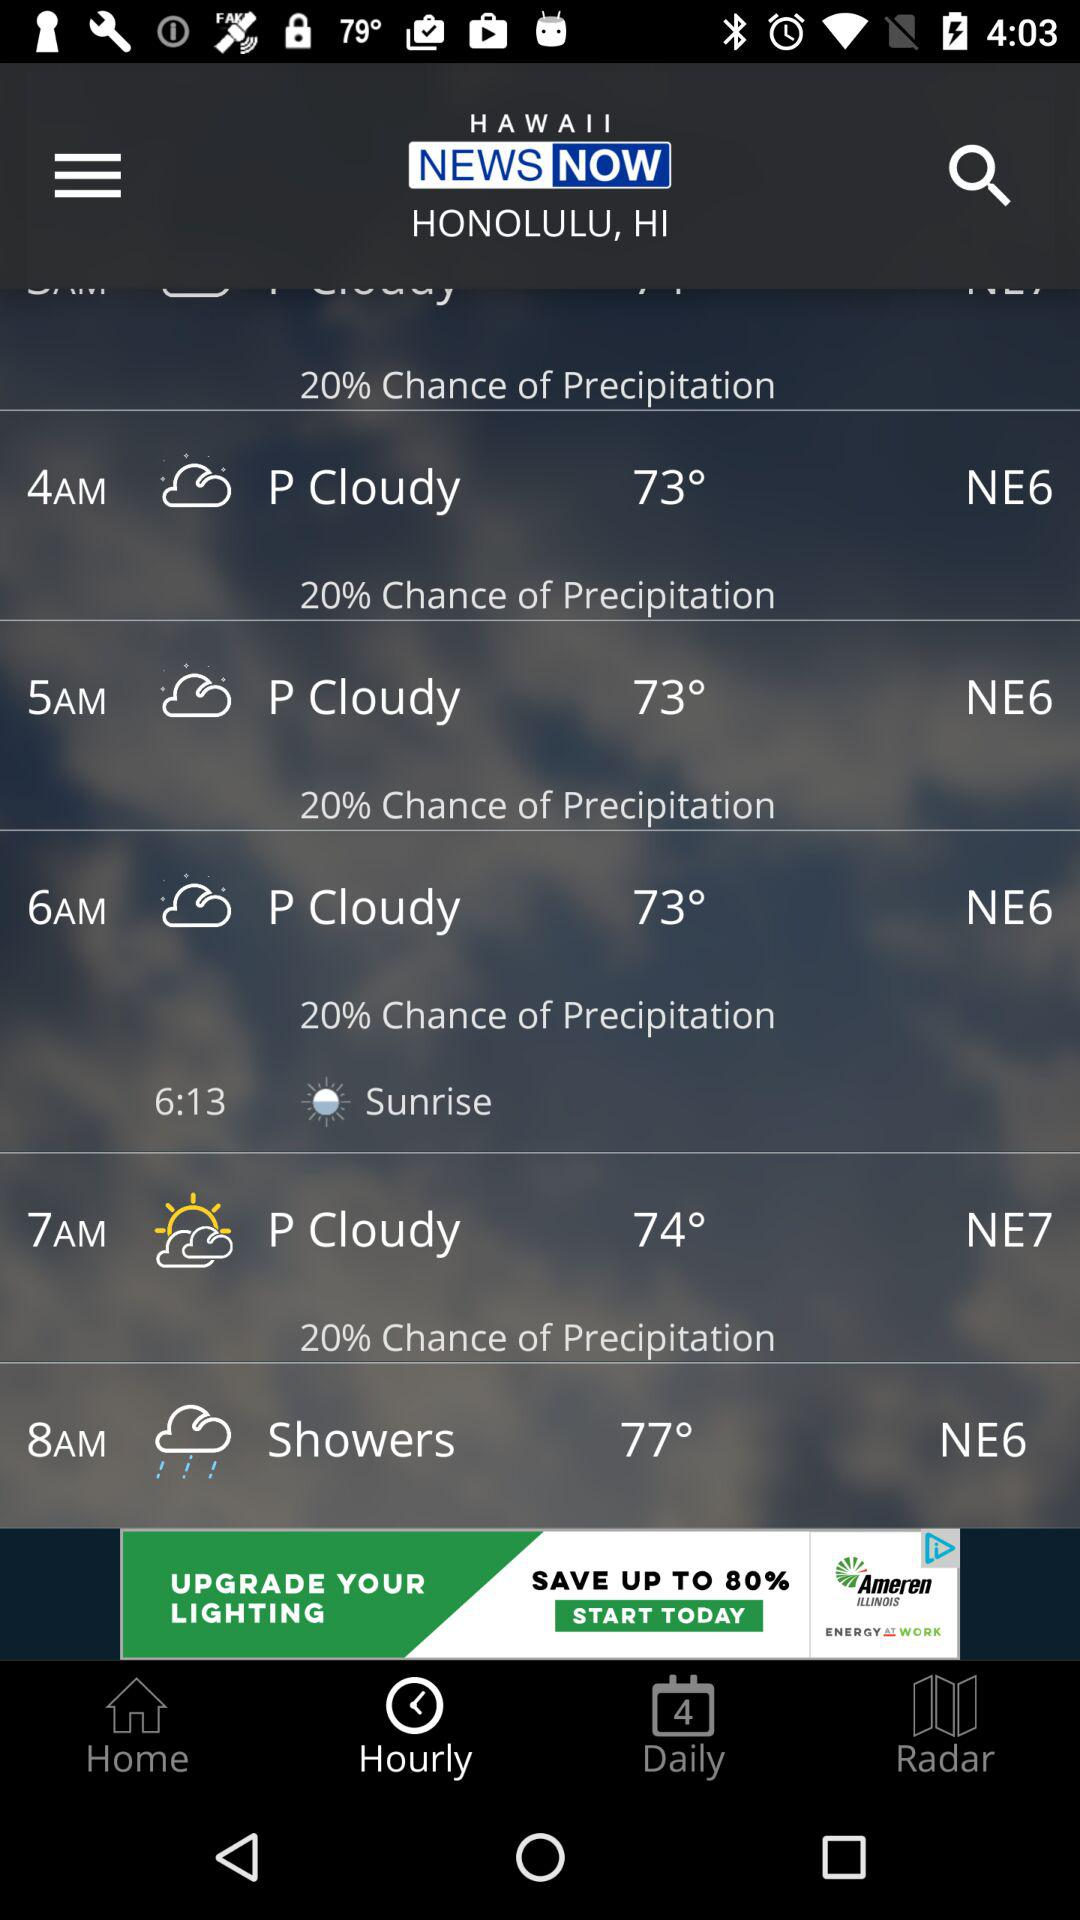What is the precipitation chance for the next 4 hours?
Answer the question using a single word or phrase. 20% 